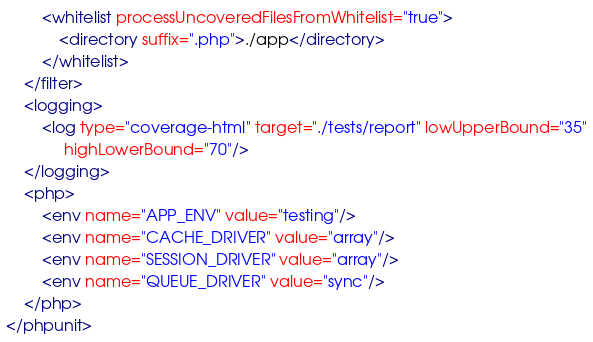<code> <loc_0><loc_0><loc_500><loc_500><_XML_>        <whitelist processUncoveredFilesFromWhitelist="true">
            <directory suffix=".php">./app</directory>
        </whitelist>
    </filter>
    <logging>
        <log type="coverage-html" target="./tests/report" lowUpperBound="35"
             highLowerBound="70"/>
    </logging>
    <php>
        <env name="APP_ENV" value="testing"/>
        <env name="CACHE_DRIVER" value="array"/>
        <env name="SESSION_DRIVER" value="array"/>
        <env name="QUEUE_DRIVER" value="sync"/>
    </php>
</phpunit>
</code> 